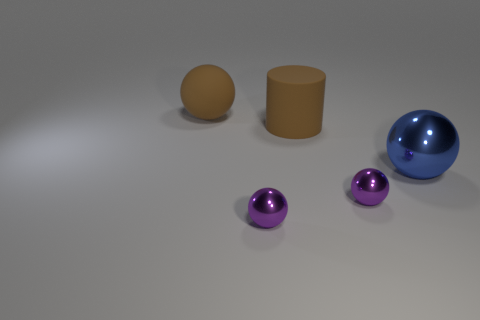What number of large objects are either blue metallic things or purple spheres?
Your answer should be very brief. 1. There is a cylinder that is the same color as the large rubber sphere; what is its size?
Give a very brief answer. Large. What is the color of the big matte thing that is in front of the sphere that is behind the blue ball?
Keep it short and to the point. Brown. Does the large brown ball have the same material as the purple object that is to the left of the large cylinder?
Your answer should be very brief. No. What is the material of the big sphere behind the blue metallic thing?
Your answer should be compact. Rubber. Is the number of small purple balls that are to the left of the big rubber cylinder the same as the number of tiny purple objects?
Keep it short and to the point. No. Is there anything else that is the same size as the rubber ball?
Offer a terse response. Yes. The tiny sphere behind the purple metallic sphere that is on the left side of the big rubber cylinder is made of what material?
Offer a very short reply. Metal. What is the shape of the object that is both to the left of the brown cylinder and in front of the cylinder?
Offer a very short reply. Sphere. The rubber thing that is the same shape as the big shiny thing is what size?
Keep it short and to the point. Large. 